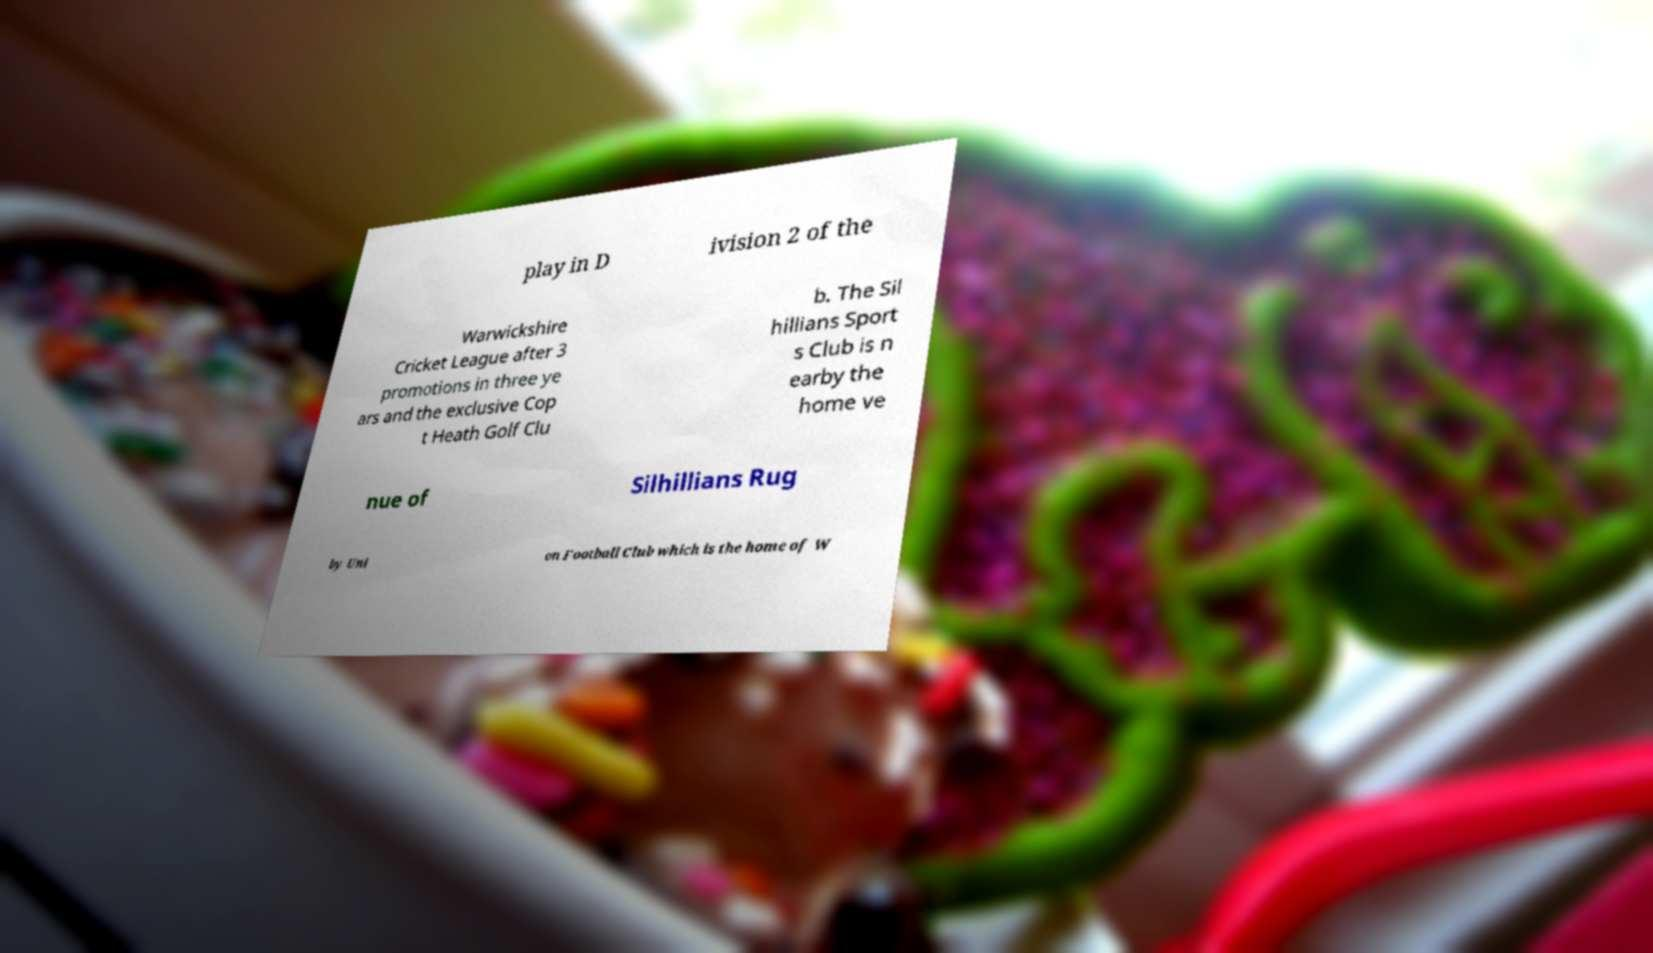Could you assist in decoding the text presented in this image and type it out clearly? play in D ivision 2 of the Warwickshire Cricket League after 3 promotions in three ye ars and the exclusive Cop t Heath Golf Clu b. The Sil hillians Sport s Club is n earby the home ve nue of Silhillians Rug by Uni on Football Club which is the home of W 